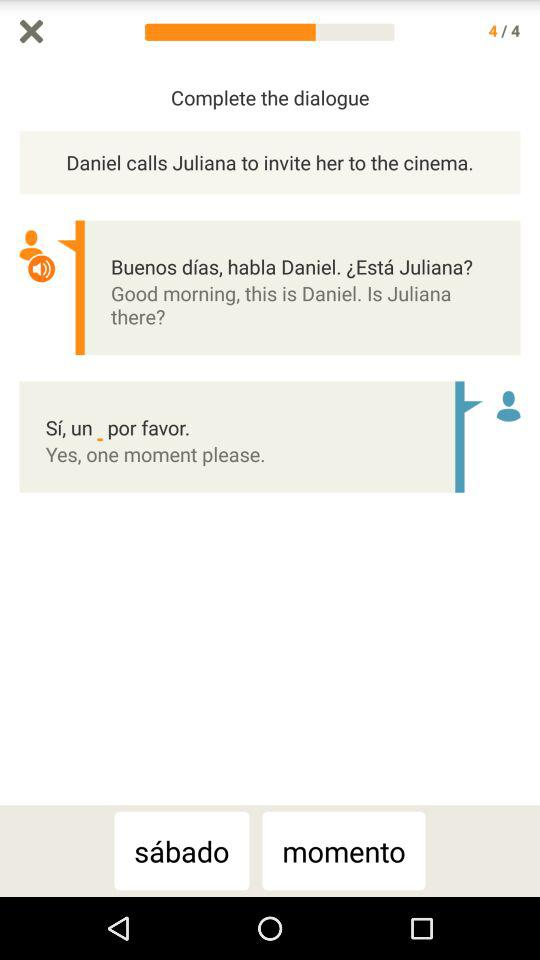When was the message sent?
When the provided information is insufficient, respond with <no answer>. <no answer> 